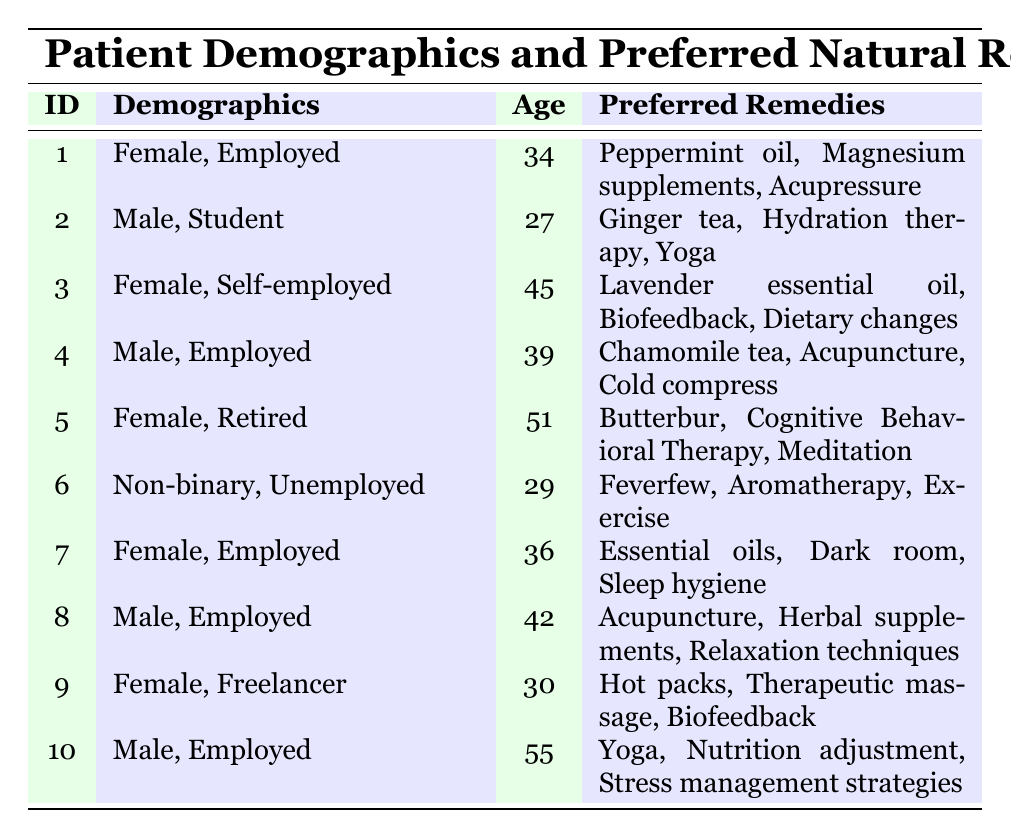What is the age of the female patient who is self-employed? The table shows that the female patient who is self-employed has an age of 45, as listed in her row.
Answer: 45 How many patients prefer "Acupuncture" as one of their remedies? By reviewing the preferred remedies in the table, both patient 4 and patient 8 have "Acupuncture" listed as a remedy, making it 2 patients.
Answer: 2 Is there a male patient aged 55? Checking the demographics in the table, patient 10 is a male and is 55 years old, so the statement is true.
Answer: Yes Which age group has the highest preferred remedy diversity? The ages 51 and 55 have the most varied remedies, with patient 5 preferring 3 diverse remedies: Butterbur, Cognitive Behavioral Therapy, and Meditation, and patient 10 preferring Yoga, Nutrition adjustment, and Stress management strategies. Thus, calculating the remedy diversity, both patients show equal diversity in their choices, making it the highest.
Answer: 51 and 55 What is the average age of female patients in the table? The ages of female patients are 34, 45, 51, 36, and 30. Summing these gives 34 + 45 + 51 + 36 + 30 = 196. Since there are 5 female patients, the average age is 196 / 5 = 39.2.
Answer: 39.2 Are there any unemployed patients among those listed? Reviewing the employment status, patient 6 is identified as unemployed, indicating that there is at least one unemployed patient.
Answer: Yes What is the most frequently mentioned natural remedy among all patients? Examining the remedies, "Acupuncture" is mentioned by 2 patients (patients 4 and 8). Combining data shows that "Biofeedback" is mentioned by 2 patients (3 and 9). Given equal references, there is no single most common remedy, as multiple remedies are favored by 2 patients each.
Answer: None How many employed female patients prefer "Sleep hygiene"? In the table, the only employed female patient is patient 7, who lists "Sleep hygiene" as one of her preferred remedies. Thus, there is only one employed female patient who prefers it.
Answer: 1 Which gender has the highest average age among the patients? The average ages are calculated as follows: Female patients (34, 45, 51, 36, 30) = 39.2; Male patients (27, 39, 42, 55) = 40.75. Since the calculation shows that the average age for males is higher, the conclusion can be made that males have a higher average age.
Answer: Male 